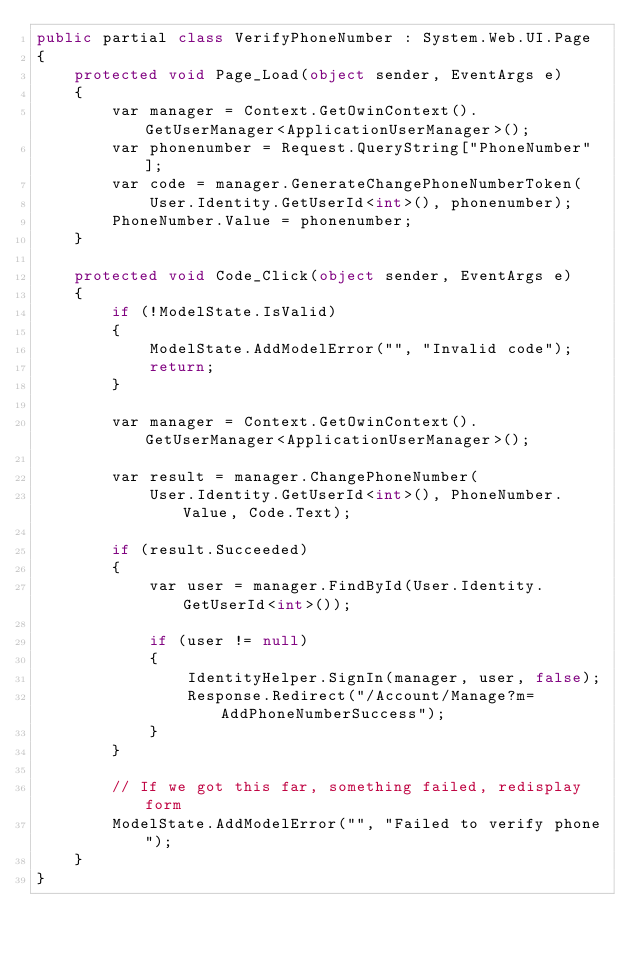<code> <loc_0><loc_0><loc_500><loc_500><_C#_>public partial class VerifyPhoneNumber : System.Web.UI.Page
{
    protected void Page_Load(object sender, EventArgs e)
    {
        var manager = Context.GetOwinContext().GetUserManager<ApplicationUserManager>();
        var phonenumber = Request.QueryString["PhoneNumber"];
        var code = manager.GenerateChangePhoneNumberToken(
            User.Identity.GetUserId<int>(), phonenumber);           
        PhoneNumber.Value = phonenumber;
    }

    protected void Code_Click(object sender, EventArgs e)
    {
        if (!ModelState.IsValid)
        {
            ModelState.AddModelError("", "Invalid code");
            return;
        }

        var manager = Context.GetOwinContext().GetUserManager<ApplicationUserManager>();

        var result = manager.ChangePhoneNumber(
            User.Identity.GetUserId<int>(), PhoneNumber.Value, Code.Text);

        if (result.Succeeded)
        {
            var user = manager.FindById(User.Identity.GetUserId<int>());

            if (user != null)
            {
                IdentityHelper.SignIn(manager, user, false);
                Response.Redirect("/Account/Manage?m=AddPhoneNumberSuccess");
            }
        }

        // If we got this far, something failed, redisplay form
        ModelState.AddModelError("", "Failed to verify phone");
    }
}</code> 